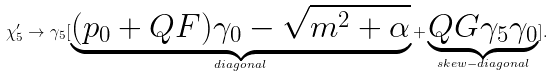Convert formula to latex. <formula><loc_0><loc_0><loc_500><loc_500>\chi _ { 5 } ^ { \prime } \rightarrow \gamma _ { 5 } [ \underbrace { ( p _ { 0 } + Q F ) \gamma _ { 0 } - \sqrt { m ^ { 2 } + \alpha } } _ { d i a g o n a l } + \underbrace { Q G \gamma _ { 5 } \gamma _ { 0 } } _ { s k e w - d i a g o n a l } ] .</formula> 